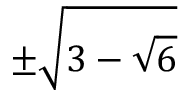Convert formula to latex. <formula><loc_0><loc_0><loc_500><loc_500>\pm \sqrt { 3 - \sqrt { 6 } }</formula> 